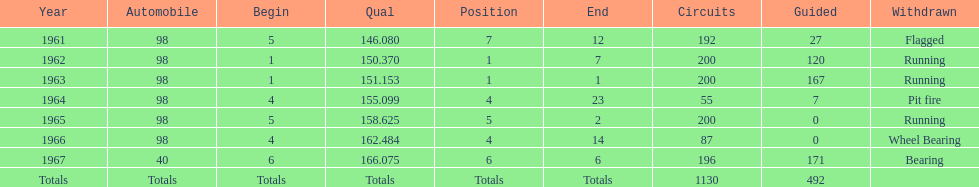How many total laps have been driven in the indy 500? 1130. 